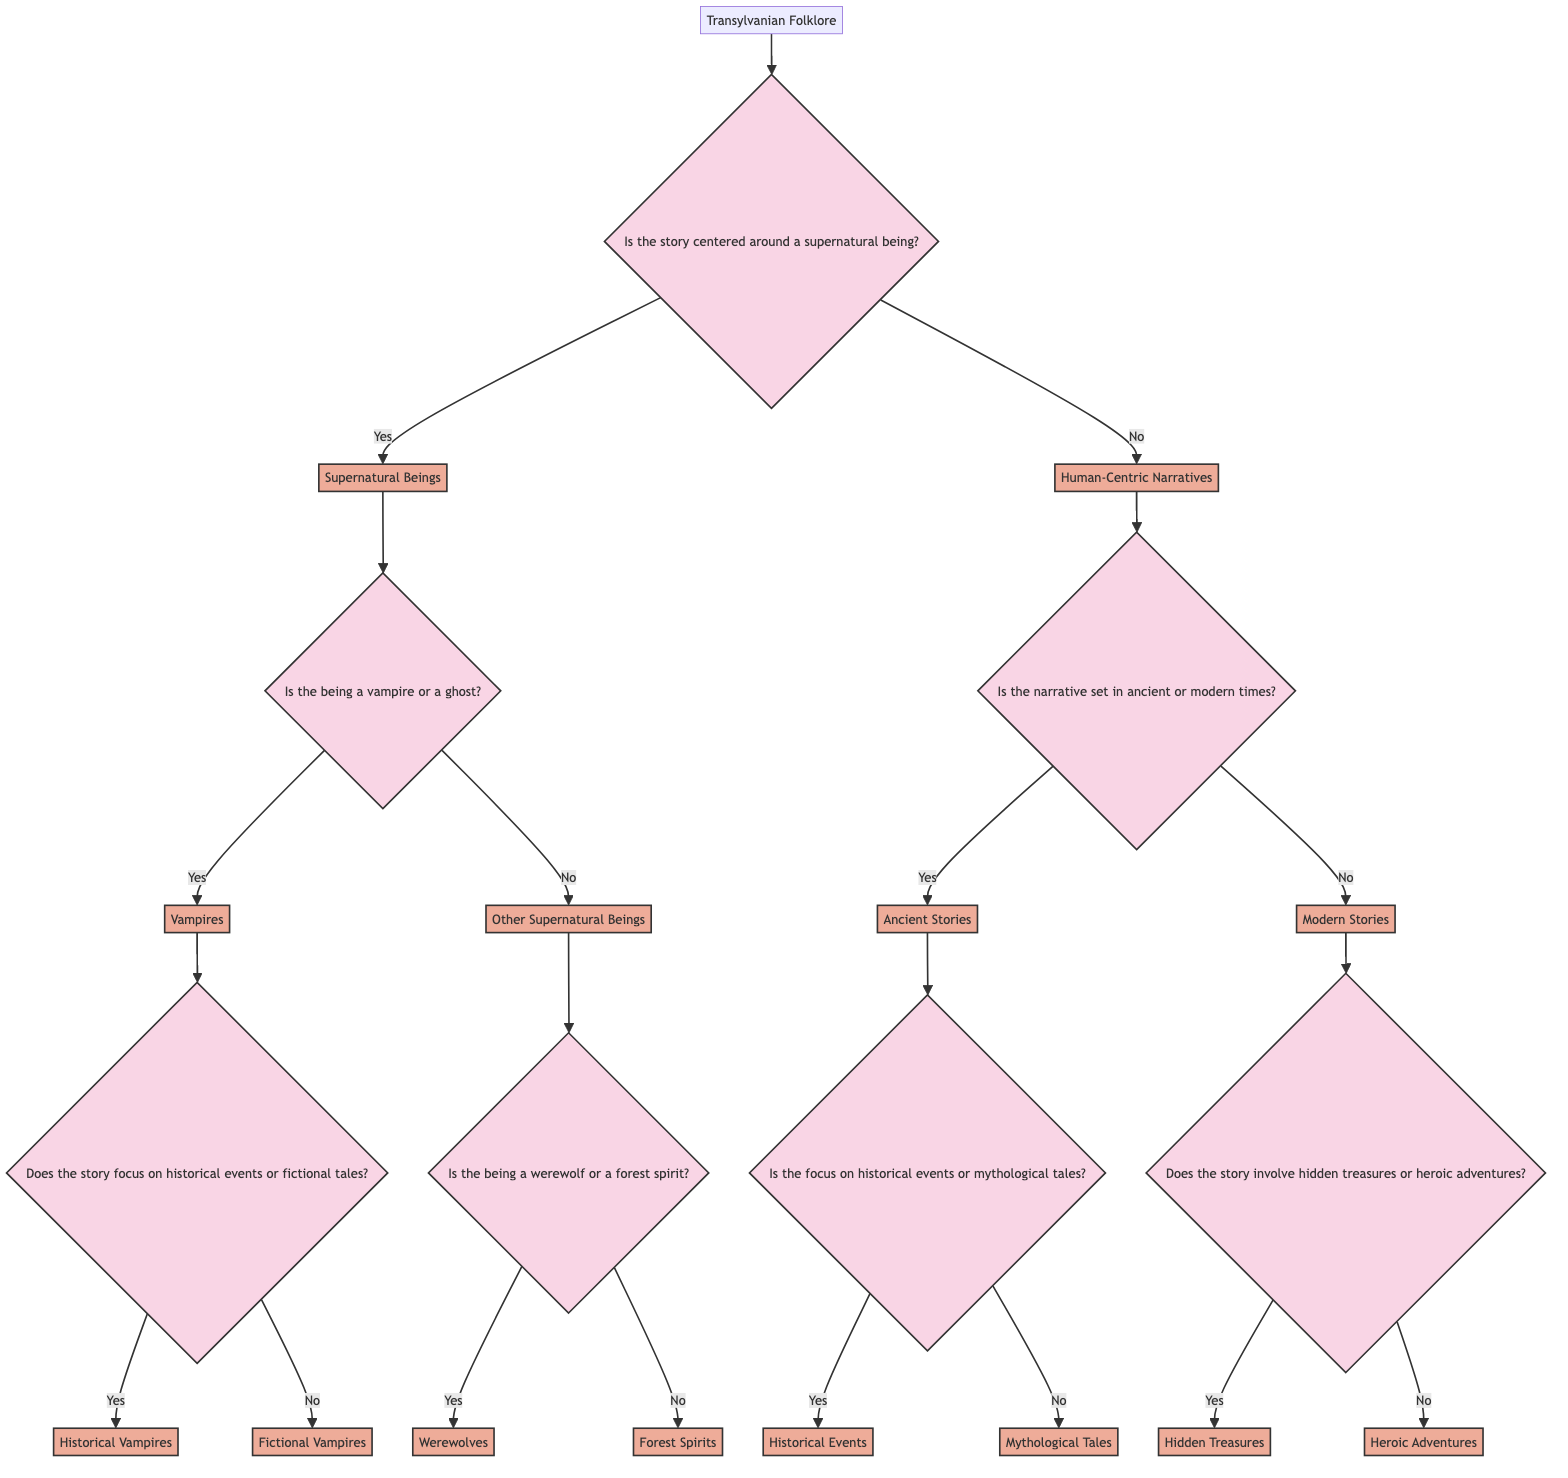What is the root of the decision tree? The root is the starting point of the diagram and represents the main topic, which in this case is Transylvanian Folklore.
Answer: Transylvanian Folklore How many main categories are there in the diagram? The diagram has two main categories: Supernatural Beings and Human-Centric Narratives, which are the first branches after the root.
Answer: Two What is the first question in the tree? The first question posed in the tree is about whether the story is centered around a supernatural being or not.
Answer: Is the story centered around a supernatural being? If a story involves vampires, what is the next question asked? If the story involves vampires, the next question is whether the story focuses on historical events or fictional tales, which further classifies the type of vampire story.
Answer: Does the story focus on historical events or fictional tales? How many types of supernatural beings are specified in the tree? The diagram specifies three types of supernatural beings: Vampires, Werewolves, and Forest Spirits, representing the classification structure based on the previous questions.
Answer: Three In Human-Centric Narratives, what two time settings are explored? The two time settings explored under Human-Centric Narratives are Ancient Stories and Modern Stories, as indicated by the branching after that category.
Answer: Ancient Stories, Modern Stories What are the two types of ancient stories? The two types under Ancient Stories are Historical Events and Mythological Tales, detailing classifications based on the focus of the story.
Answer: Historical Events, Mythological Tales If a modern story involves hidden treasures, what is the next category? If a modern story involves hidden treasures, it falls into the category of Hidden Treasures, as indicated by the decisions outlined in the diagram.
Answer: Hidden Treasures What type of supernatural being is classified if it is neither a vampire nor a ghost? If the supernatural being is neither a vampire nor a ghost, it could be classified as either Werewolves or Forest Spirits depending on further questioning.
Answer: Werewolves, Forest Spirits 